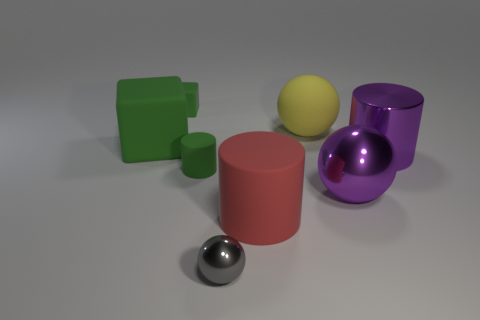Add 2 red rubber objects. How many objects exist? 10 Subtract all cylinders. How many objects are left? 5 Add 7 big cubes. How many big cubes are left? 8 Add 8 green blocks. How many green blocks exist? 10 Subtract 0 brown cylinders. How many objects are left? 8 Subtract all big red rubber cylinders. Subtract all tiny brown rubber things. How many objects are left? 7 